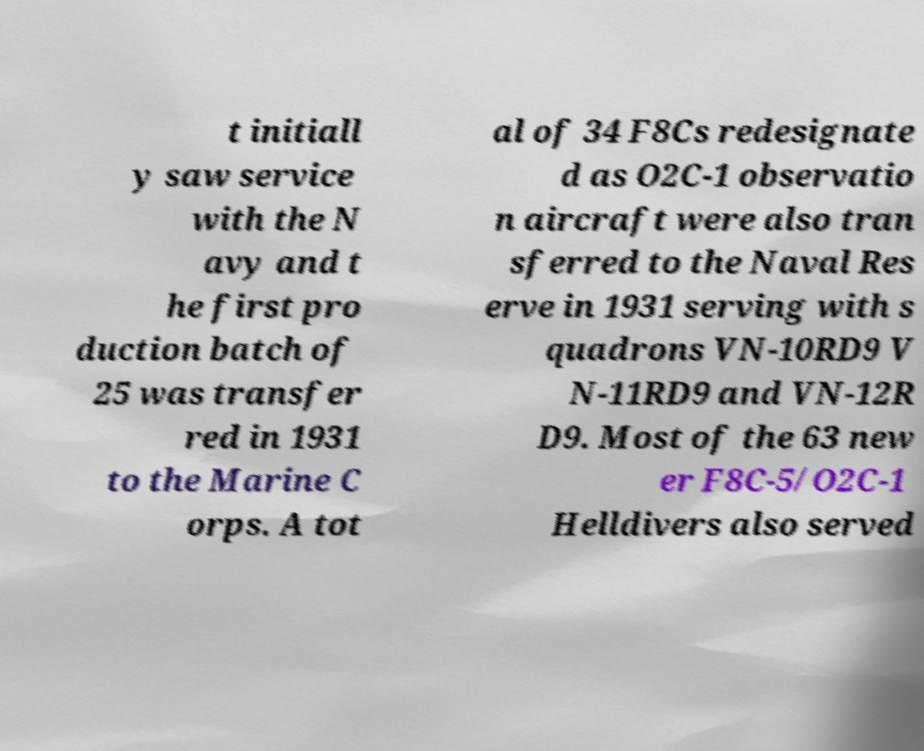There's text embedded in this image that I need extracted. Can you transcribe it verbatim? t initiall y saw service with the N avy and t he first pro duction batch of 25 was transfer red in 1931 to the Marine C orps. A tot al of 34 F8Cs redesignate d as O2C-1 observatio n aircraft were also tran sferred to the Naval Res erve in 1931 serving with s quadrons VN-10RD9 V N-11RD9 and VN-12R D9. Most of the 63 new er F8C-5/O2C-1 Helldivers also served 